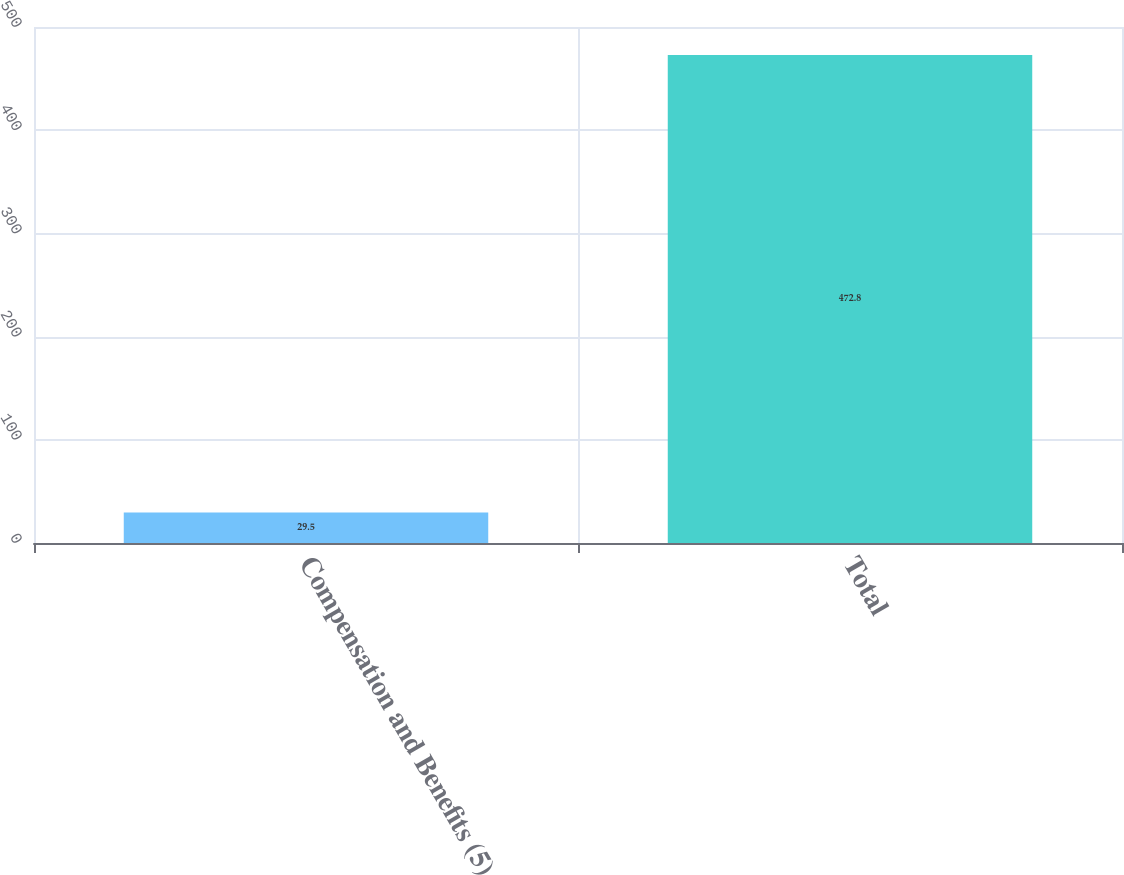Convert chart. <chart><loc_0><loc_0><loc_500><loc_500><bar_chart><fcel>Compensation and Benefits (5)<fcel>Total<nl><fcel>29.5<fcel>472.8<nl></chart> 